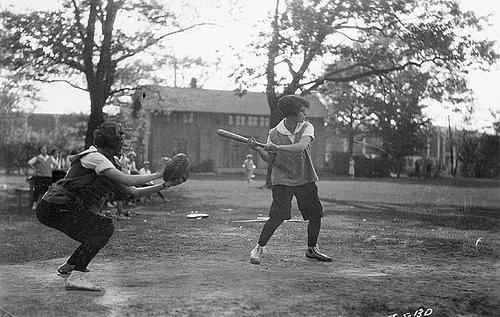How many people are there?
Give a very brief answer. 2. 